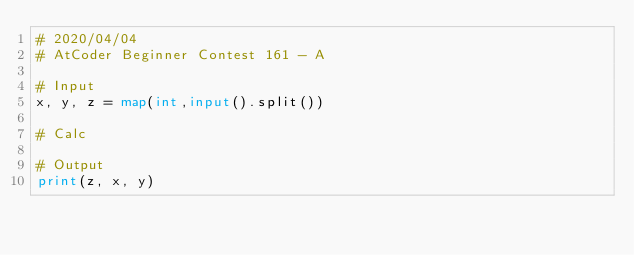Convert code to text. <code><loc_0><loc_0><loc_500><loc_500><_Python_># 2020/04/04
# AtCoder Beginner Contest 161 - A

# Input
x, y, z = map(int,input().split())

# Calc

# Output
print(z, x, y)
</code> 